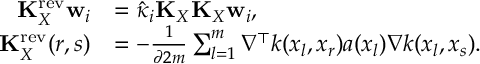<formula> <loc_0><loc_0><loc_500><loc_500>\begin{array} { r l } { K _ { X } ^ { r e v } w _ { i } } & { = \hat { \kappa } _ { i } K _ { X } K _ { X } w _ { i } , } \\ { K _ { X } ^ { r e v } ( r , s ) } & { = - \frac { 1 } { \partial 2 m } \sum _ { l = 1 } ^ { m } \nabla ^ { \top } k ( x _ { l } , x _ { r } ) a ( x _ { l } ) \nabla k ( x _ { l } , x _ { s } ) . } \end{array}</formula> 